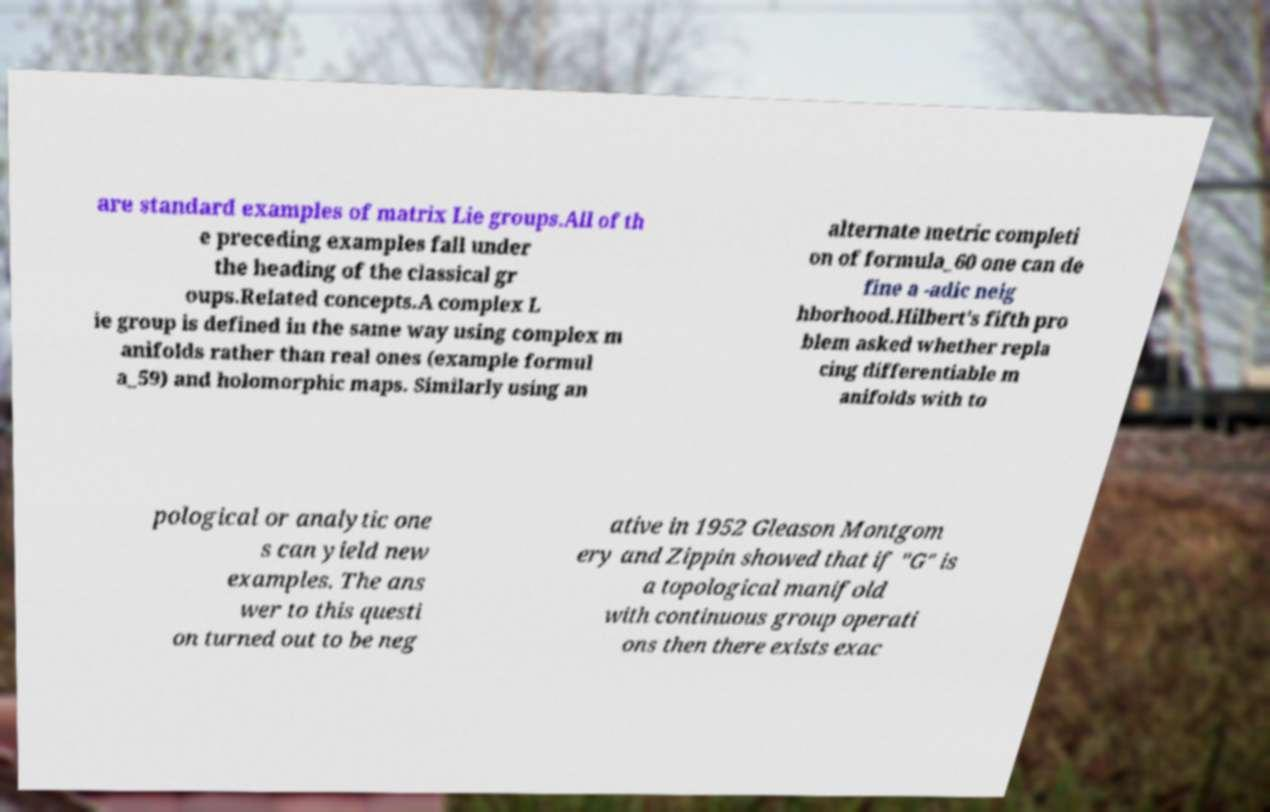Please read and relay the text visible in this image. What does it say? are standard examples of matrix Lie groups.All of th e preceding examples fall under the heading of the classical gr oups.Related concepts.A complex L ie group is defined in the same way using complex m anifolds rather than real ones (example formul a_59) and holomorphic maps. Similarly using an alternate metric completi on of formula_60 one can de fine a -adic neig hborhood.Hilbert's fifth pro blem asked whether repla cing differentiable m anifolds with to pological or analytic one s can yield new examples. The ans wer to this questi on turned out to be neg ative in 1952 Gleason Montgom ery and Zippin showed that if "G" is a topological manifold with continuous group operati ons then there exists exac 